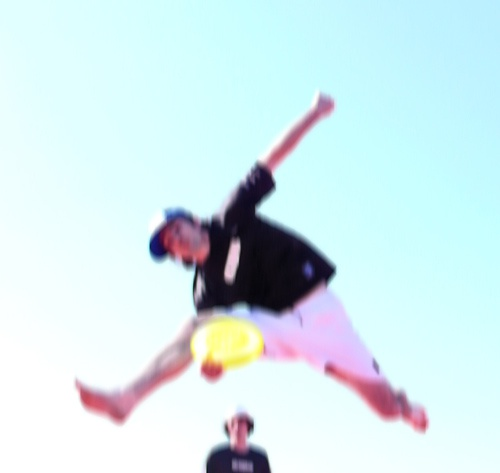Describe the objects in this image and their specific colors. I can see people in lightblue, black, lavender, pink, and khaki tones, frisbee in lightblue, khaki, beige, and orange tones, and people in lightblue, black, gray, lavender, and navy tones in this image. 